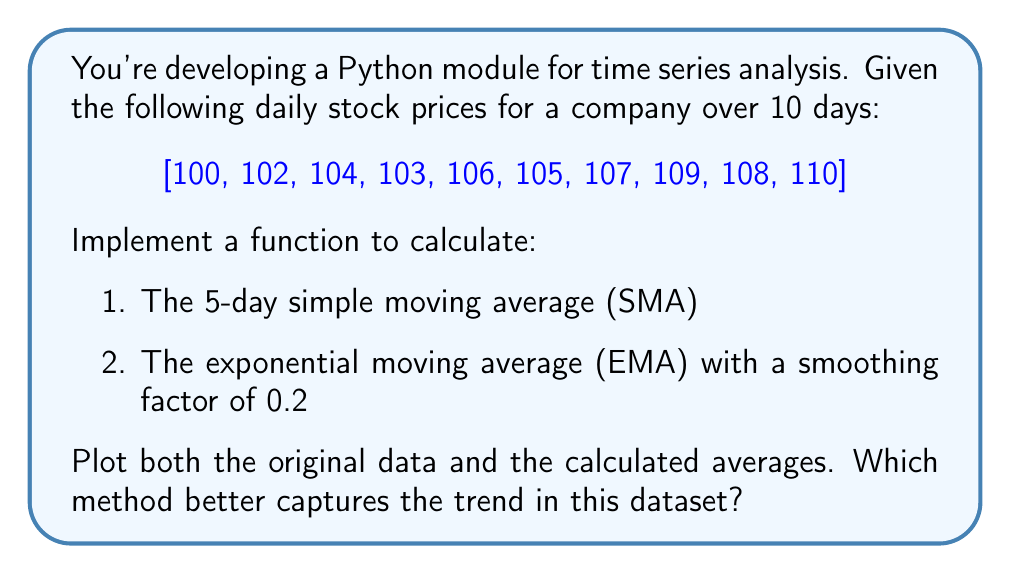Give your solution to this math problem. Let's break this down step-by-step:

1. Simple Moving Average (SMA):
   The 5-day SMA is calculated by taking the average of the last 5 days' prices.
   
   For the given data, we can calculate the SMA as follows:
   
   $$SMA_t = \frac{1}{5} \sum_{i=t-4}^{t} P_i$$
   
   where $P_i$ is the price on day $i$.
   
   The SMA values will be:
   - Day 5: $\frac{100 + 102 + 104 + 103 + 106}{5} = 103$
   - Day 6: $\frac{102 + 104 + 103 + 106 + 105}{5} = 104$
   - Day 7: $\frac{104 + 103 + 106 + 105 + 107}{5} = 105$
   - Day 8: $\frac{103 + 106 + 105 + 107 + 109}{5} = 106$
   - Day 9: $\frac{106 + 105 + 107 + 109 + 108}{5} = 107$
   - Day 10: $\frac{105 + 107 + 109 + 108 + 110}{5} = 107.8$

2. Exponential Moving Average (EMA):
   The EMA gives more weight to recent prices and is calculated as:
   
   $$EMA_t = \alpha \cdot P_t + (1 - \alpha) \cdot EMA_{t-1}$$
   
   where $\alpha$ is the smoothing factor (0.2 in this case) and $P_t$ is the price at time $t$.
   
   We'll use the first day's price as the initial EMA.
   
   The EMA values will be:
   - Day 1: $EMA_1 = 100$
   - Day 2: $0.2 \cdot 102 + 0.8 \cdot 100 = 100.4$
   - Day 3: $0.2 \cdot 104 + 0.8 \cdot 100.4 = 101.12$
   - Day 4: $0.2 \cdot 103 + 0.8 \cdot 101.12 = 101.496$
   - Day 5: $0.2 \cdot 106 + 0.8 \cdot 101.496 = 102.3968$
   - Day 6: $0.2 \cdot 105 + 0.8 \cdot 102.3968 = 102.91744$
   - Day 7: $0.2 \cdot 107 + 0.8 \cdot 102.91744 = 103.733952$
   - Day 8: $0.2 \cdot 109 + 0.8 \cdot 103.733952 = 104.7871616$
   - Day 9: $0.2 \cdot 108 + 0.8 \cdot 104.7871616 = 105.42972928$
   - Day 10: $0.2 \cdot 110 + 0.8 \cdot 105.42972928 = 106.343783424$

To visualize this, we can plot the original data, SMA, and EMA:

[asy]
import graph;
size(300,200);

real[] prices = {100,102,104,103,106,105,107,109,108,110};
real[] sma = {0,0,0,0,103,104,105,106,107,107.8};
real[] ema = {100,100.4,101.12,101.496,102.3968,102.91744,103.733952,104.7871616,105.42972928,106.343783424};

for(int i=0; i<10; ++i) {
  dot((i+1,prices[i]), blue);
  if(i>=4) dot((i+1,sma[i]), red);
  dot((i+1,ema[i]), green);
}

draw(graph(prices,1,10), blue, "Original");
draw(graph(sma,5,10), red, "SMA");
draw(graph(ema,1,10), green, "EMA");

xaxis("Days", 0, 11, Arrow);
yaxis("Price", 98, 112, Arrow);

legend("Original", blue, E, 1, 0);
legend("SMA", red, E, 1, 0);
legend("EMA", green, E, 1, 0);
[/asy]

Comparing the two methods:
1. The SMA provides a smoother line but lags behind the actual trend.
2. The EMA responds more quickly to recent price changes and follows the trend more closely.

In this dataset, the EMA better captures the overall upward trend, especially the sharp increase in the latter half of the period. The SMA, while smoothing out short-term fluctuations, doesn't reflect the recent upward movement as quickly.
Answer: EMA better captures the trend, providing quicker response to recent changes. 